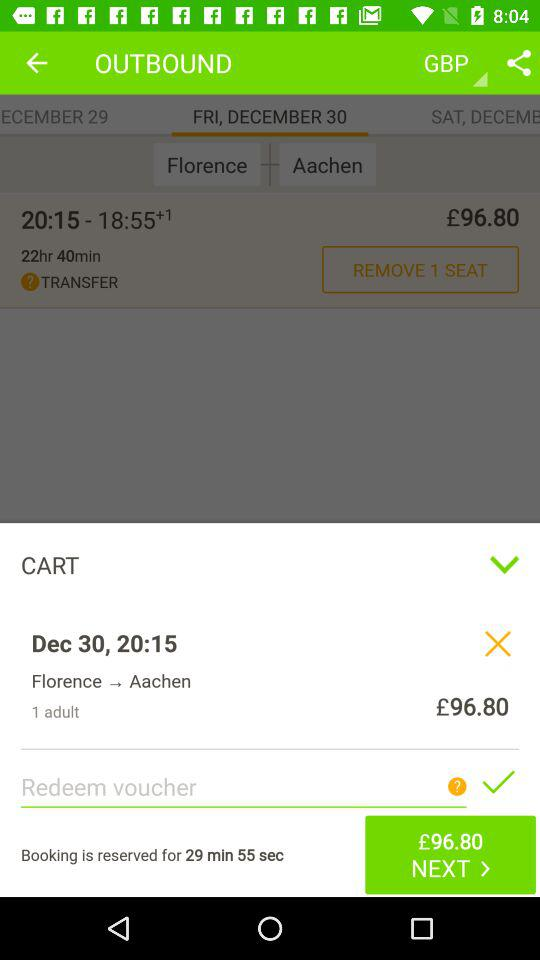What is the final destination shown on the screen? The final destination shown on the screen is "Aachen". 